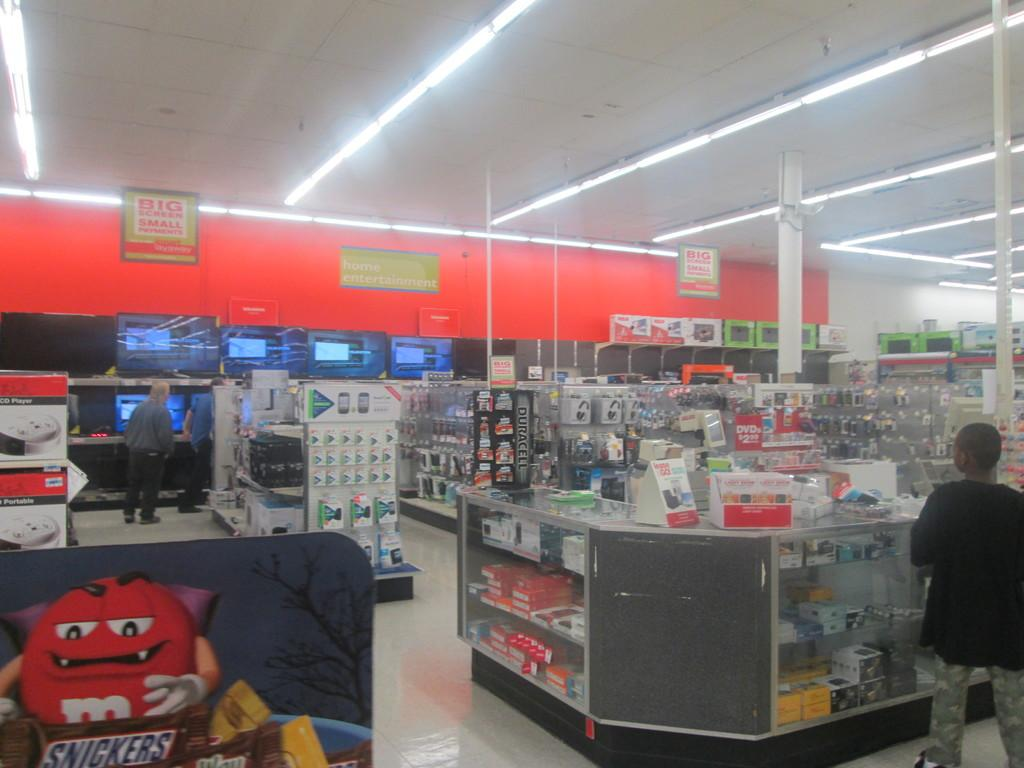<image>
Describe the image concisely. Inside a store, there is a M and M vampire about to eat a snickers bar. 